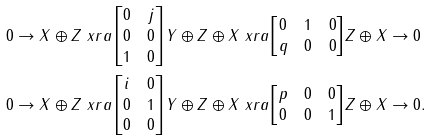<formula> <loc_0><loc_0><loc_500><loc_500>& 0 \to X \oplus Z \ x r a { \begin{bmatrix} 0 & j \\ 0 & 0 \\ 1 & 0 \end{bmatrix} } Y \oplus Z \oplus X \ x r a { \begin{bmatrix} 0 & 1 & 0 \\ q & 0 & 0 \end{bmatrix} } Z \oplus X \to 0 \\ & 0 \to X \oplus Z \ x r a { \begin{bmatrix} i & 0 \\ 0 & 1 \\ 0 & 0 \end{bmatrix} } Y \oplus Z \oplus X \ x r a { \begin{bmatrix} p & 0 & 0 \\ 0 & 0 & 1 \end{bmatrix} } Z \oplus X \to 0 .</formula> 